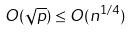<formula> <loc_0><loc_0><loc_500><loc_500>O ( \sqrt { p } ) \leq O ( n ^ { 1 / 4 } )</formula> 